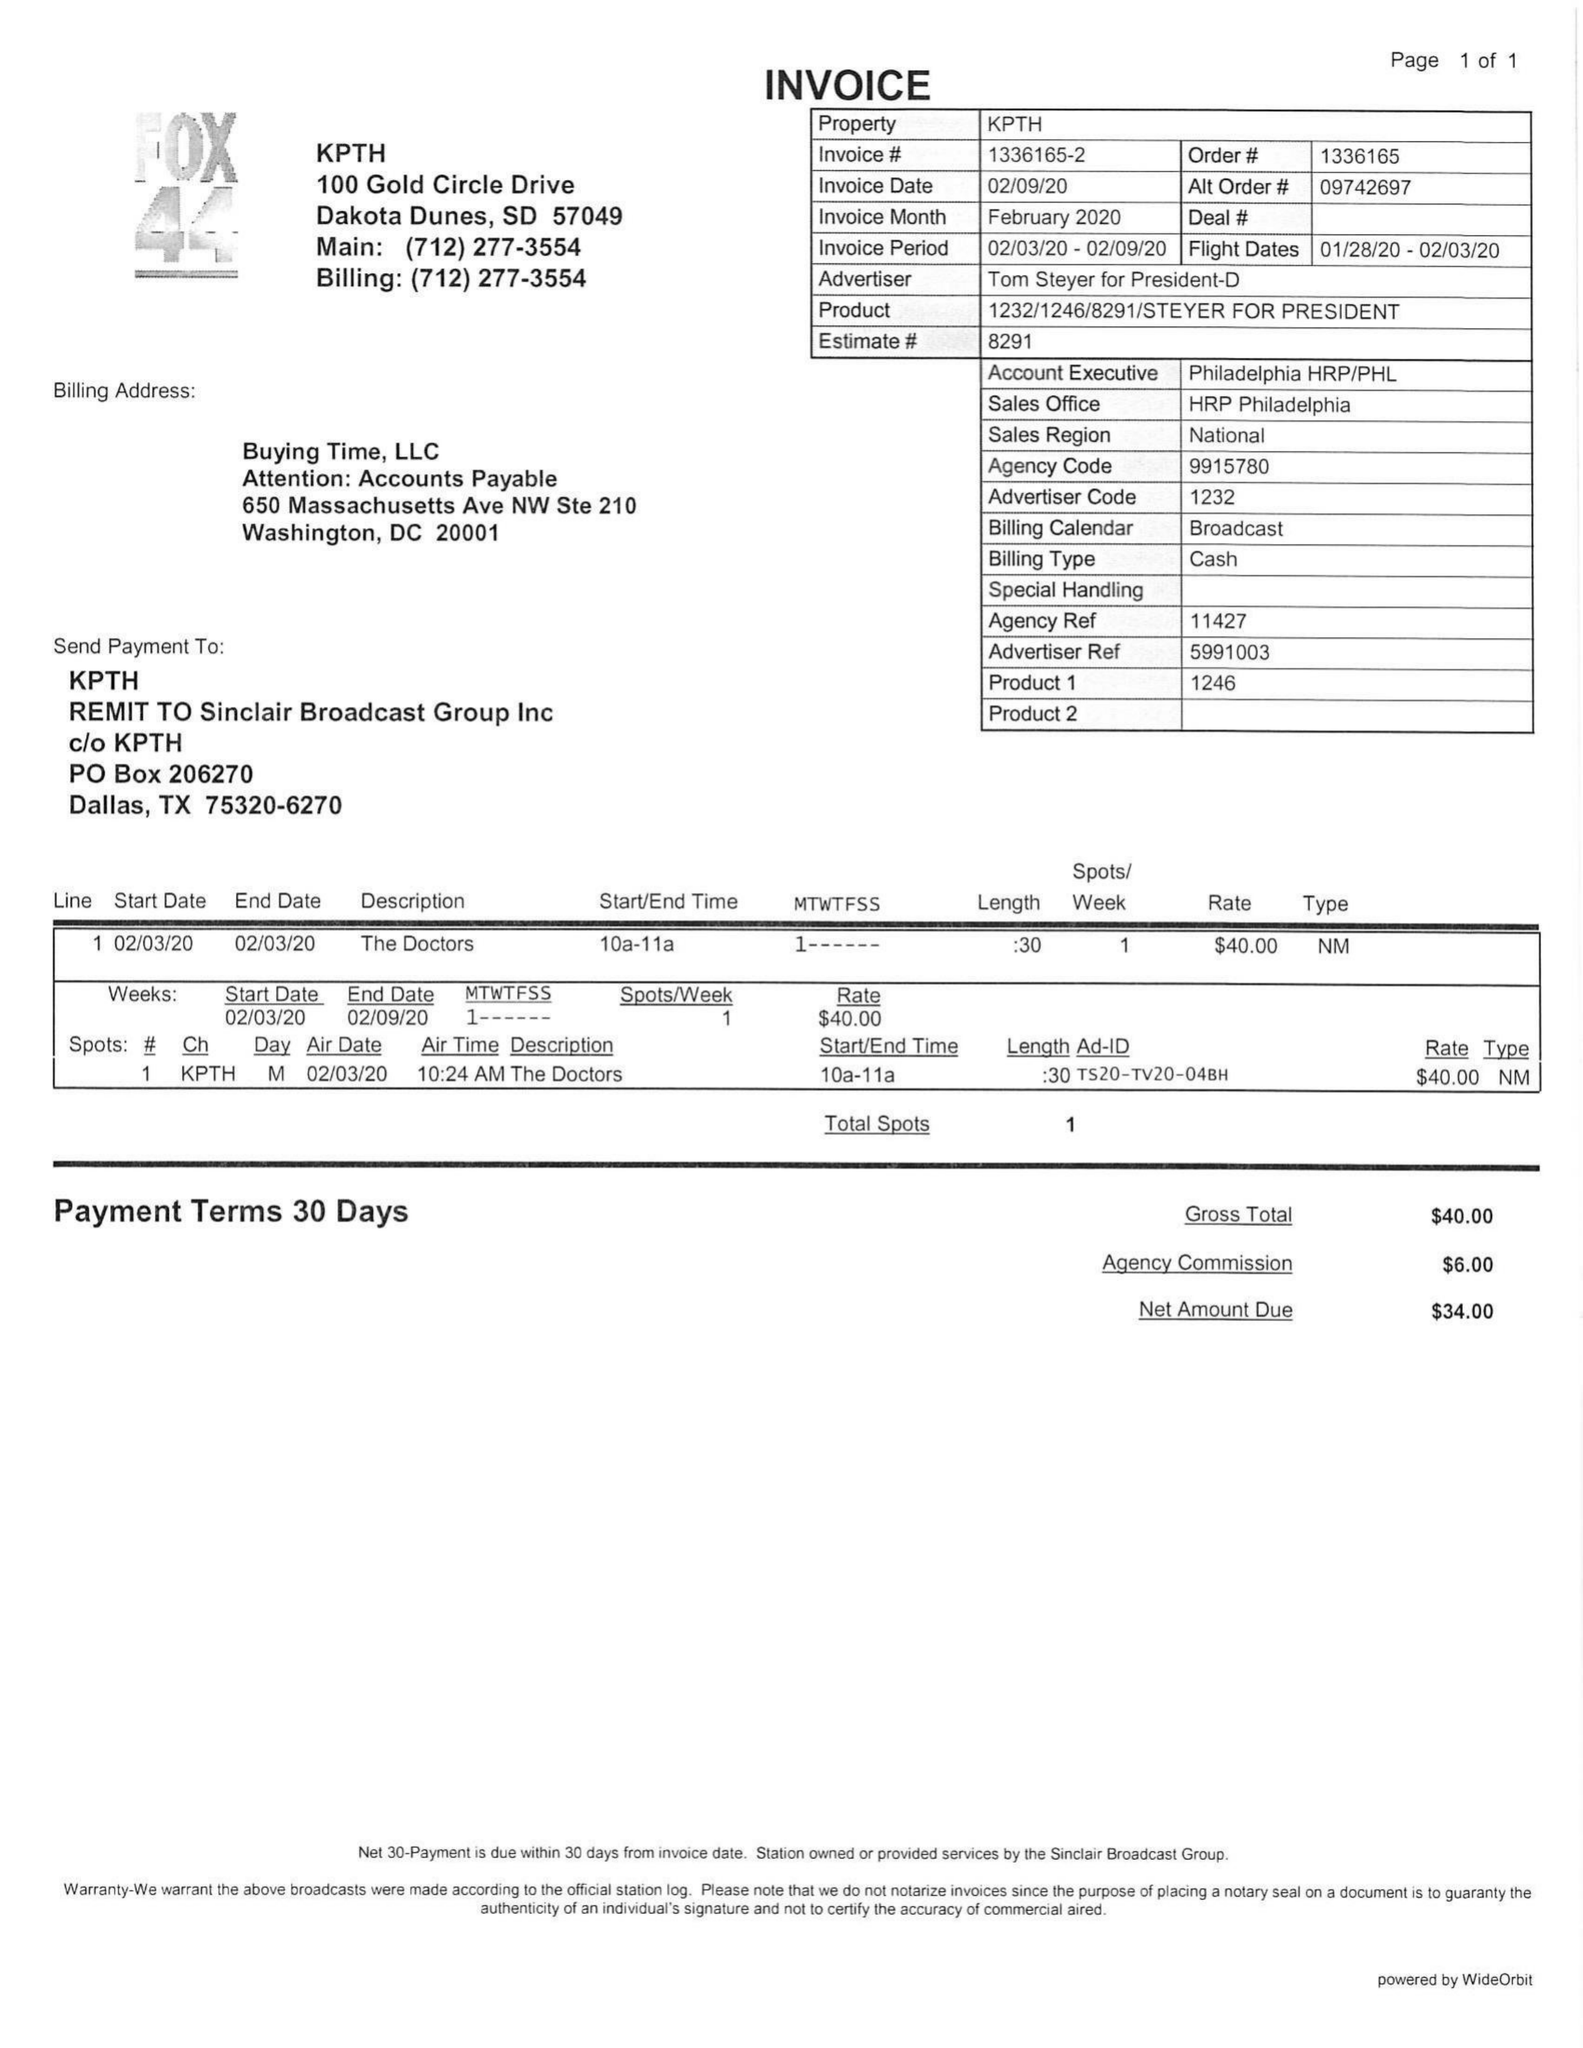What is the value for the flight_from?
Answer the question using a single word or phrase. 01/28/20 